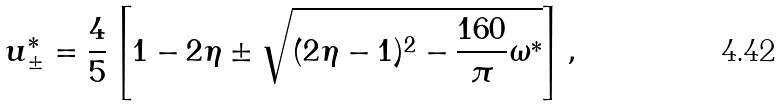Convert formula to latex. <formula><loc_0><loc_0><loc_500><loc_500>u ^ { * } _ { \pm } = \frac { 4 } { 5 } \left [ 1 - 2 \eta \pm \sqrt { ( 2 \eta - 1 ) ^ { 2 } - \frac { 1 6 0 } { \pi } \omega ^ { * } } \right ] ,</formula> 